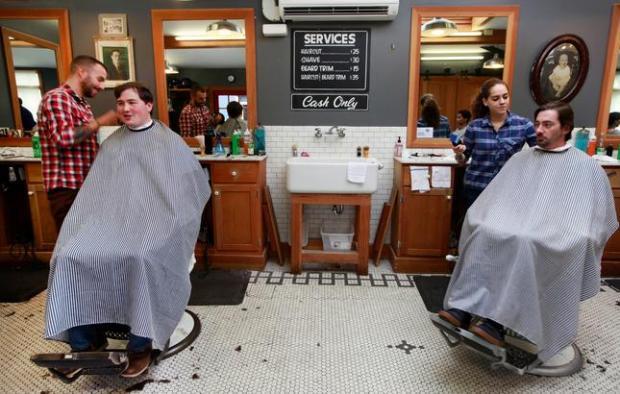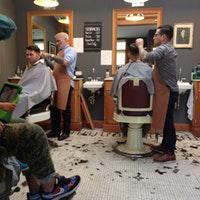The first image is the image on the left, the second image is the image on the right. Considering the images on both sides, is "Nobody is getting a haircut in the left image, but someone is in the right image." valid? Answer yes or no. No. The first image is the image on the left, the second image is the image on the right. Considering the images on both sides, is "People are getting their haircut in exactly one image." valid? Answer yes or no. No. 